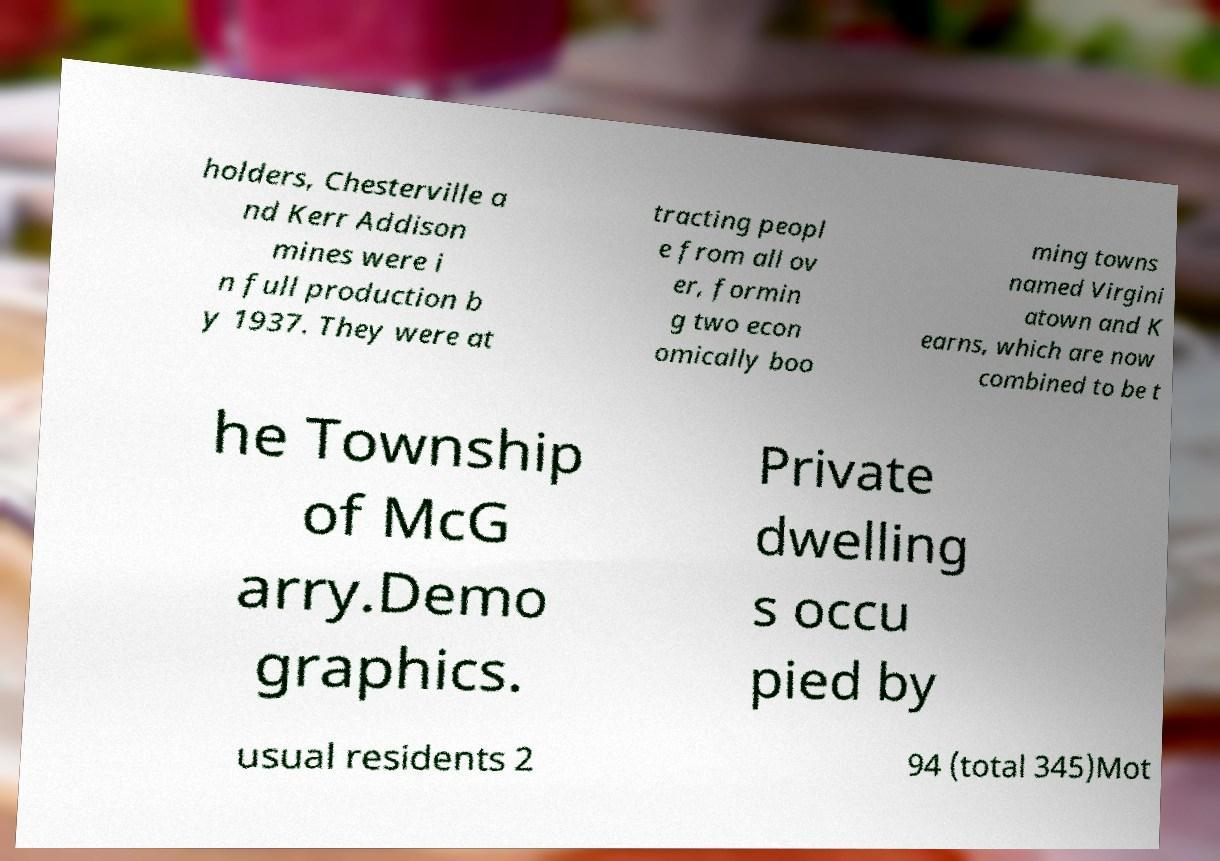Can you read and provide the text displayed in the image?This photo seems to have some interesting text. Can you extract and type it out for me? holders, Chesterville a nd Kerr Addison mines were i n full production b y 1937. They were at tracting peopl e from all ov er, formin g two econ omically boo ming towns named Virgini atown and K earns, which are now combined to be t he Township of McG arry.Demo graphics. Private dwelling s occu pied by usual residents 2 94 (total 345)Mot 